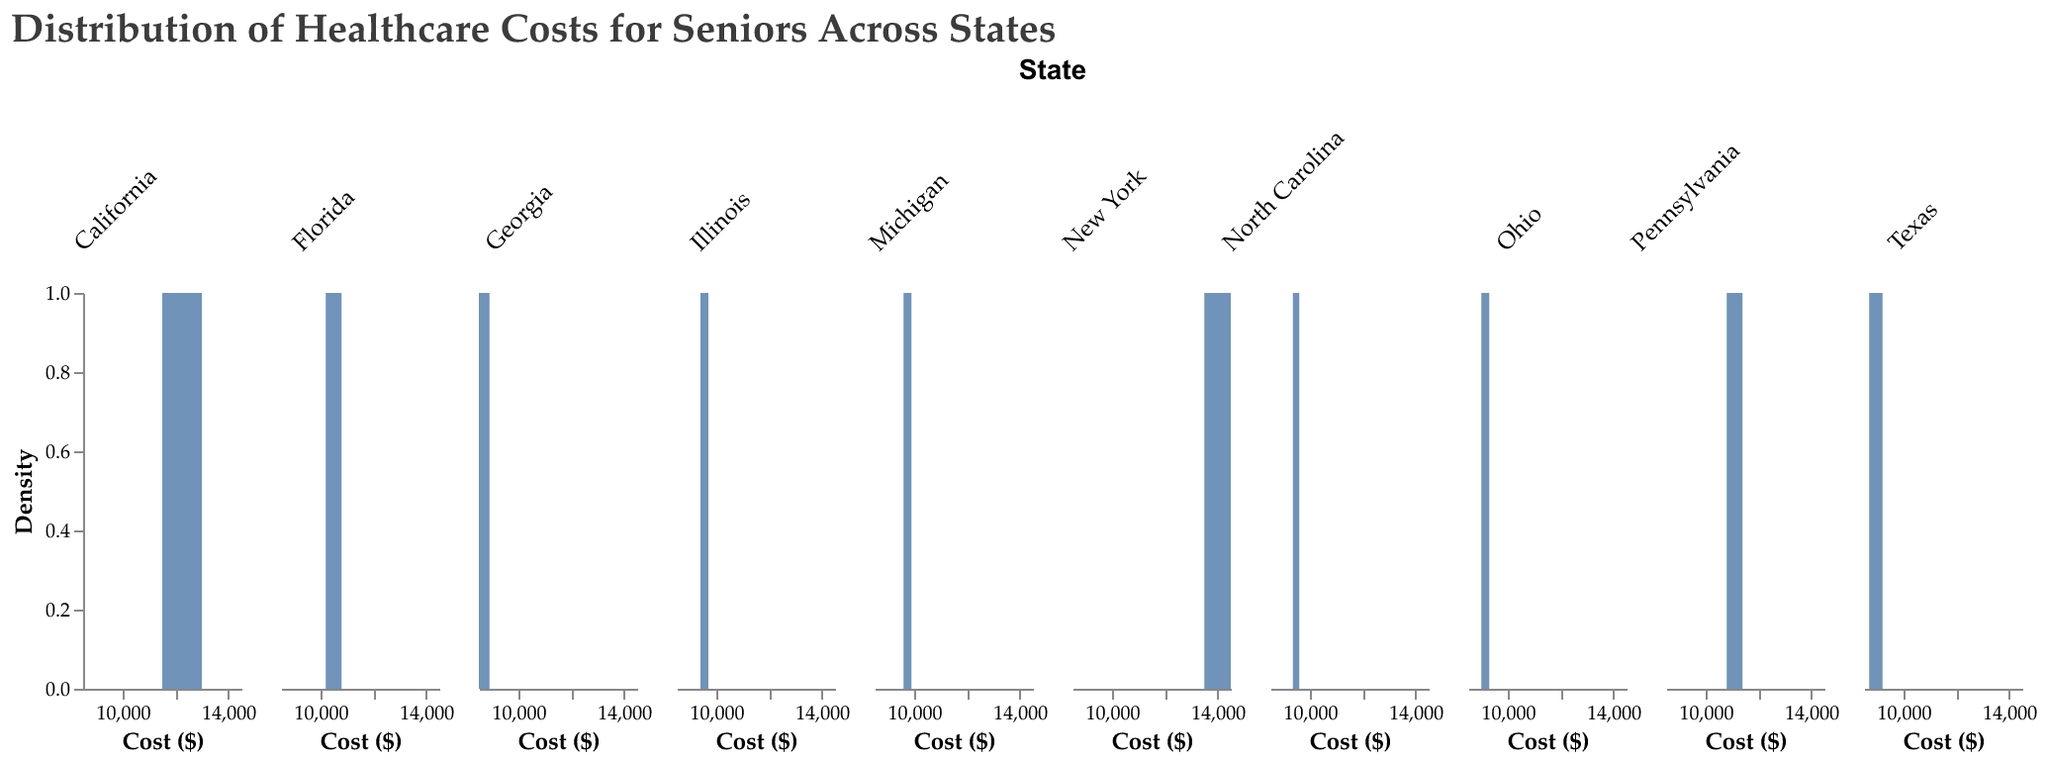What's the title of the figure? The title of the figure is displayed clearly at the top, which helps in understanding the main subject of the visualization.
Answer: Distribution of Healthcare Costs for Seniors Across States What cost range is shown for California on the X-axis? Observing the X-axis specifically for California, the range of healthcare costs displayed is identified.
Answer: 11,500 to 13,000 dollars Which State shows the highest peak in density, indicating the most common healthcare costs? By looking at how high the peaks are, we can determine which state's density plot has the most pronounced peak, reflecting the most common healthcare costs.
Answer: New York How do the healthcare costs in New York compare to those in Texas? Comparing the density plots of New York and Texas, higher costs are indicated by the rightward shift, while lower costs are shown on the left.
Answer: New York has higher healthcare costs than Texas Which state has a more spread-out distribution of healthcare costs, Michigan or Florida? Examining the spread of the densities, a wider spread indicates more variability in costs.
Answer: Michigan What is the median value of healthcare costs in North Carolina? To determine the median, observe the density plot and identify the midpoint value where half the data lies on each side.
Answer: 9450 dollars Which state has the lowest density peak, indicating less commonality in healthcare costs? The state with the lowest peak in its density plot suggests a broader spread or less commonality in costs.
Answer: Georgia Which state shows a dense concentration around 9000 dollars in healthcare costs? Analyzing the density plots for concentrations around specific figures, we identify states with densities around 9000 dollars.
Answer: Texas What is the average range of healthcare costs for Illinois as shown in the plot? Identifying the bounds of Illinois' density plot on the X-axis provides the range over which data points are distributed.
Answer: 9400 to 9700 dollars 